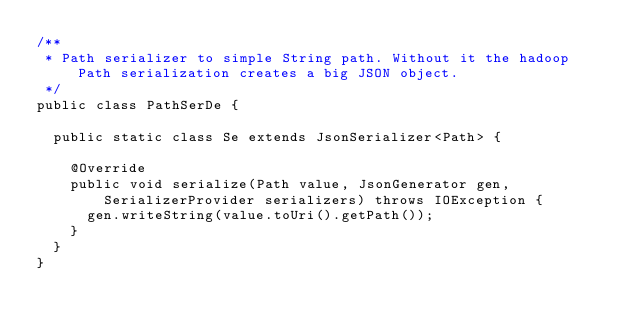Convert code to text. <code><loc_0><loc_0><loc_500><loc_500><_Java_>/**
 * Path serializer to simple String path. Without it the hadoop Path serialization creates a big JSON object.
 */
public class PathSerDe {

  public static class Se extends JsonSerializer<Path> {

    @Override
    public void serialize(Path value, JsonGenerator gen, SerializerProvider serializers) throws IOException {
      gen.writeString(value.toUri().getPath());
    }
  }
}
</code> 